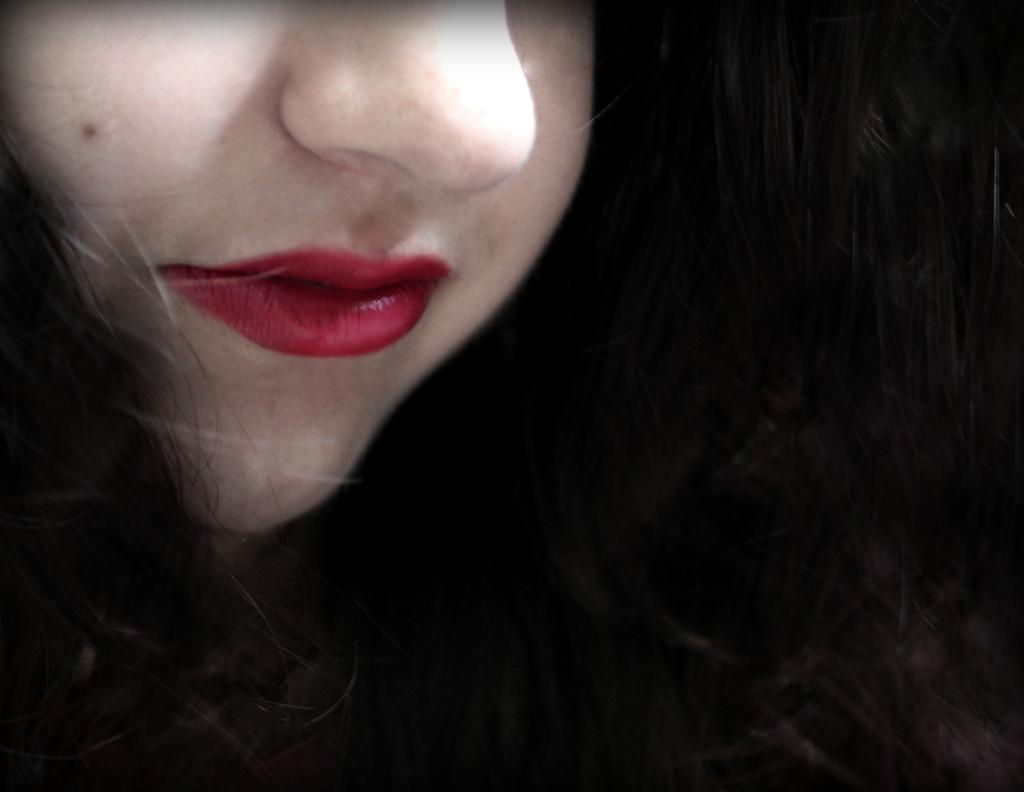Who is the main subject in the image? There is a woman in the image. What can be seen in relation to the woman's appearance? The woman's hair is visible in the image. How much of the woman's face can be seen in the image? Half of the woman's face is visible in the image. What credit card does the woman use in the image? There is no credit card visible in the image, and the woman's use of a credit card cannot be determined from the image. 